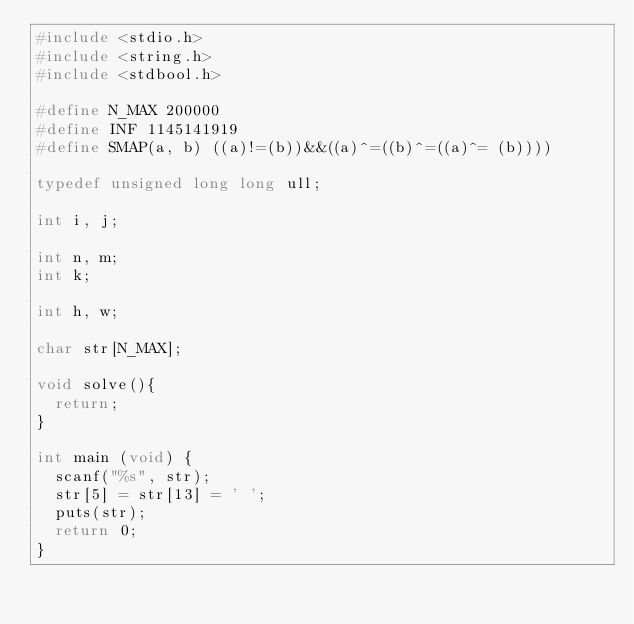<code> <loc_0><loc_0><loc_500><loc_500><_C_>#include <stdio.h>
#include <string.h>
#include <stdbool.h>

#define N_MAX 200000
#define INF 1145141919
#define SMAP(a, b) ((a)!=(b))&&((a)^=((b)^=((a)^= (b))))

typedef unsigned long long ull;

int i, j;

int n, m;
int k;

int h, w;

char str[N_MAX];

void solve(){
	return;
}

int main (void) {
	scanf("%s", str);
	str[5] = str[13] = ' ';
	puts(str);
	return 0;
}


</code> 